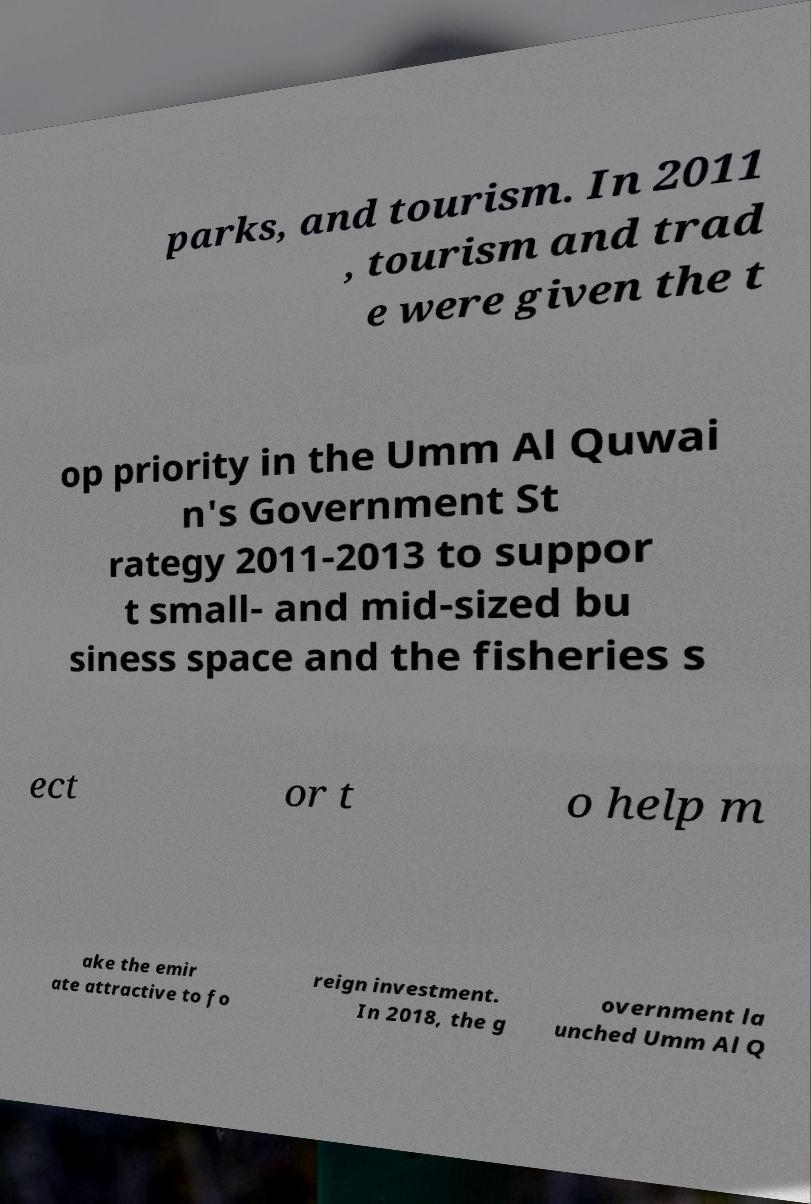Can you read and provide the text displayed in the image?This photo seems to have some interesting text. Can you extract and type it out for me? parks, and tourism. In 2011 , tourism and trad e were given the t op priority in the Umm Al Quwai n's Government St rategy 2011-2013 to suppor t small- and mid-sized bu siness space and the fisheries s ect or t o help m ake the emir ate attractive to fo reign investment. In 2018, the g overnment la unched Umm Al Q 